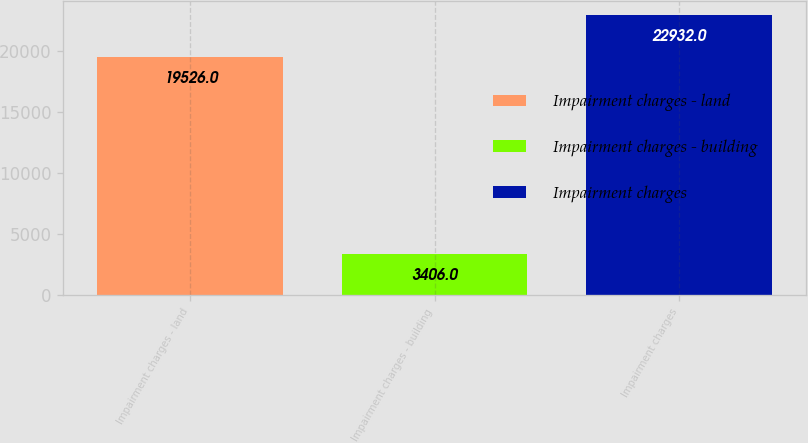<chart> <loc_0><loc_0><loc_500><loc_500><bar_chart><fcel>Impairment charges - land<fcel>Impairment charges - building<fcel>Impairment charges<nl><fcel>19526<fcel>3406<fcel>22932<nl></chart> 